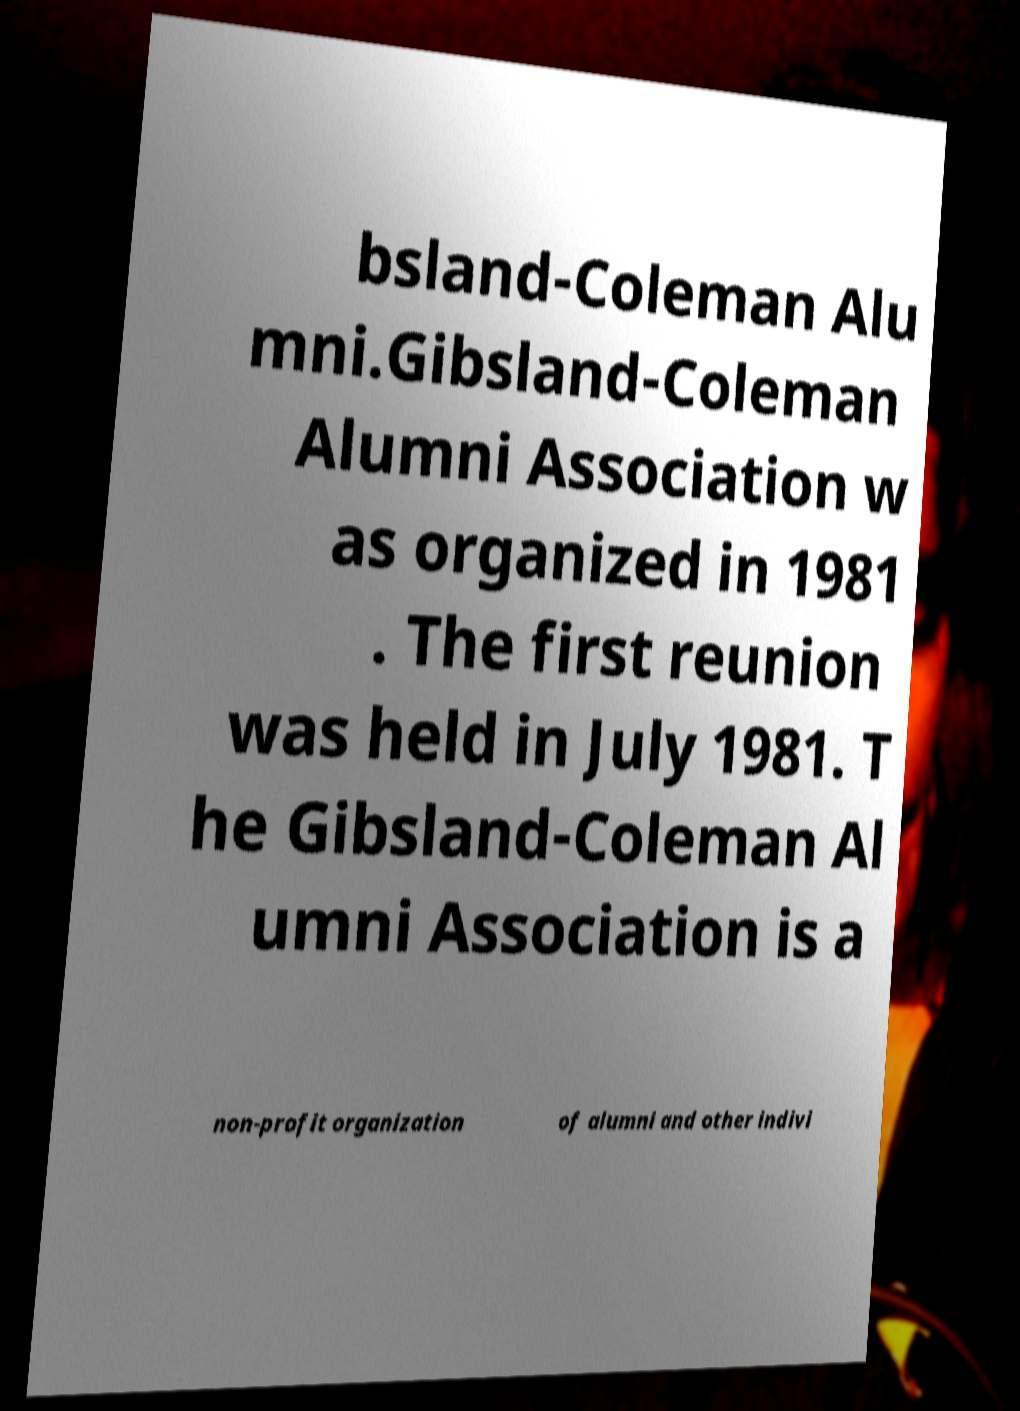Could you assist in decoding the text presented in this image and type it out clearly? bsland-Coleman Alu mni.Gibsland-Coleman Alumni Association w as organized in 1981 . The first reunion was held in July 1981. T he Gibsland-Coleman Al umni Association is a non-profit organization of alumni and other indivi 